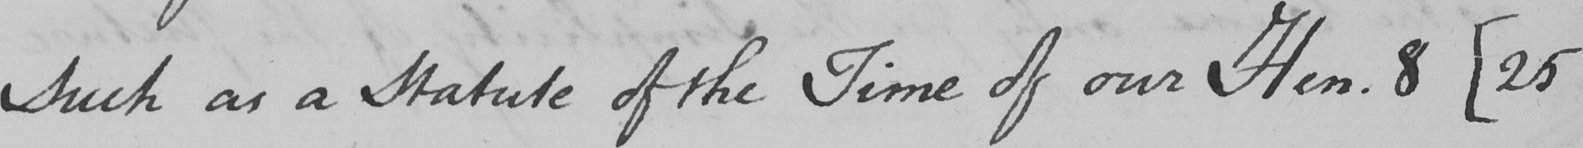What is written in this line of handwriting? Such as a Statute of the Time of our Hen . 8  [ 25 